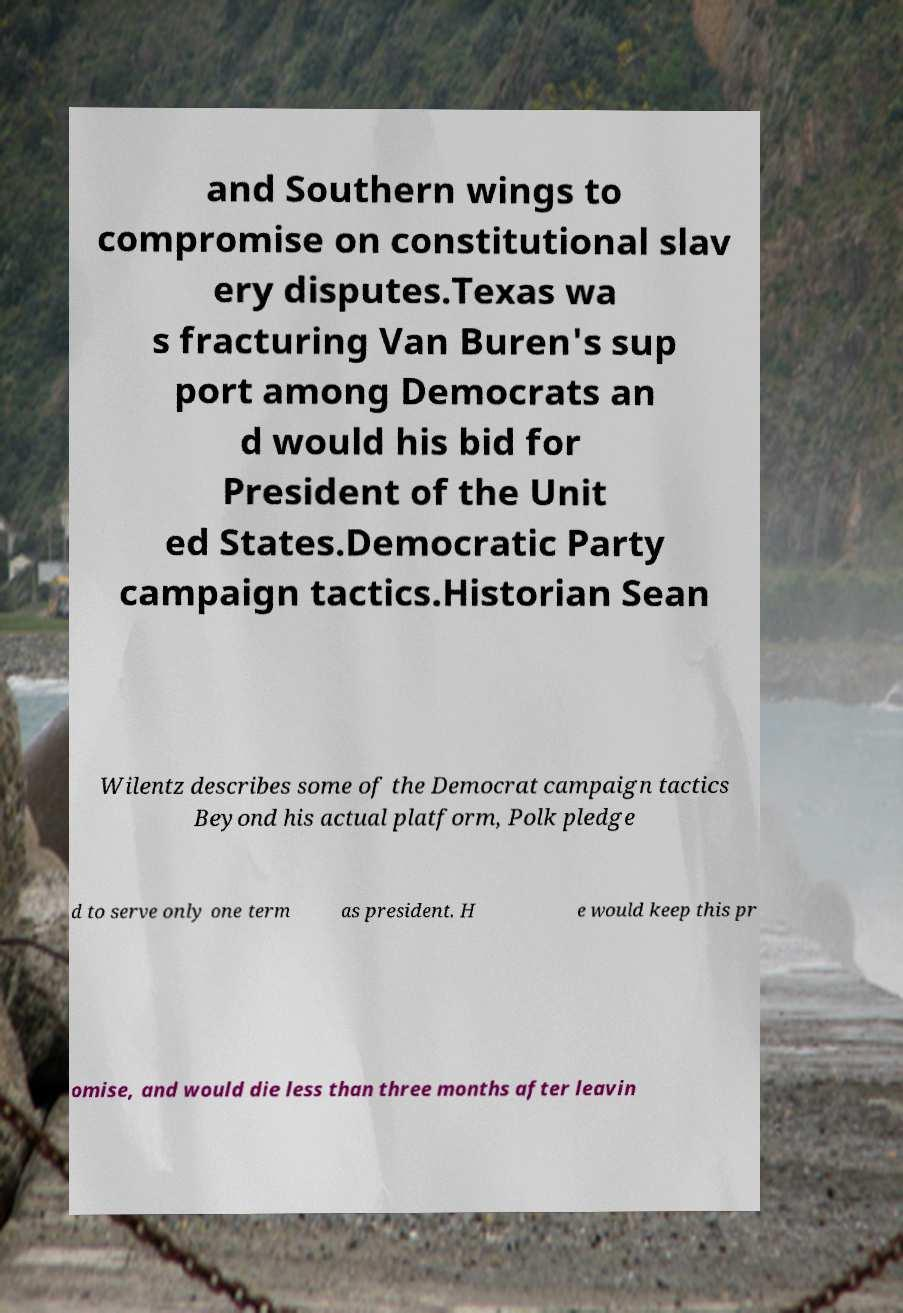Could you extract and type out the text from this image? and Southern wings to compromise on constitutional slav ery disputes.Texas wa s fracturing Van Buren's sup port among Democrats an d would his bid for President of the Unit ed States.Democratic Party campaign tactics.Historian Sean Wilentz describes some of the Democrat campaign tactics Beyond his actual platform, Polk pledge d to serve only one term as president. H e would keep this pr omise, and would die less than three months after leavin 